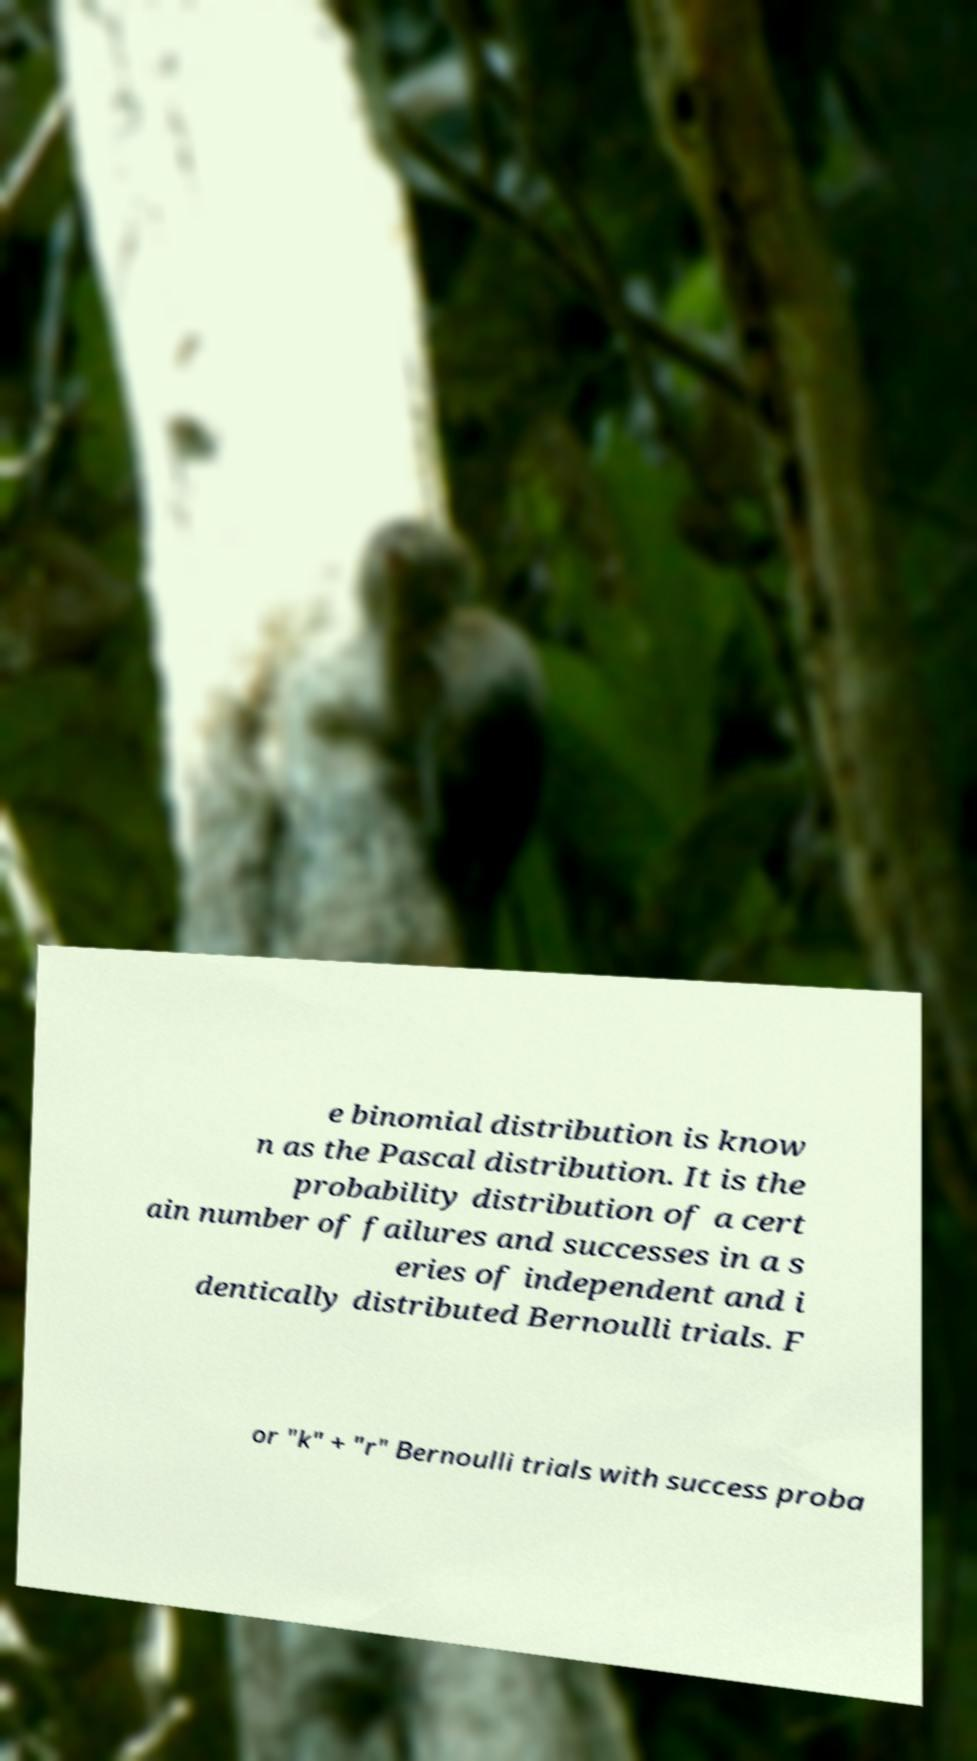What messages or text are displayed in this image? I need them in a readable, typed format. e binomial distribution is know n as the Pascal distribution. It is the probability distribution of a cert ain number of failures and successes in a s eries of independent and i dentically distributed Bernoulli trials. F or "k" + "r" Bernoulli trials with success proba 